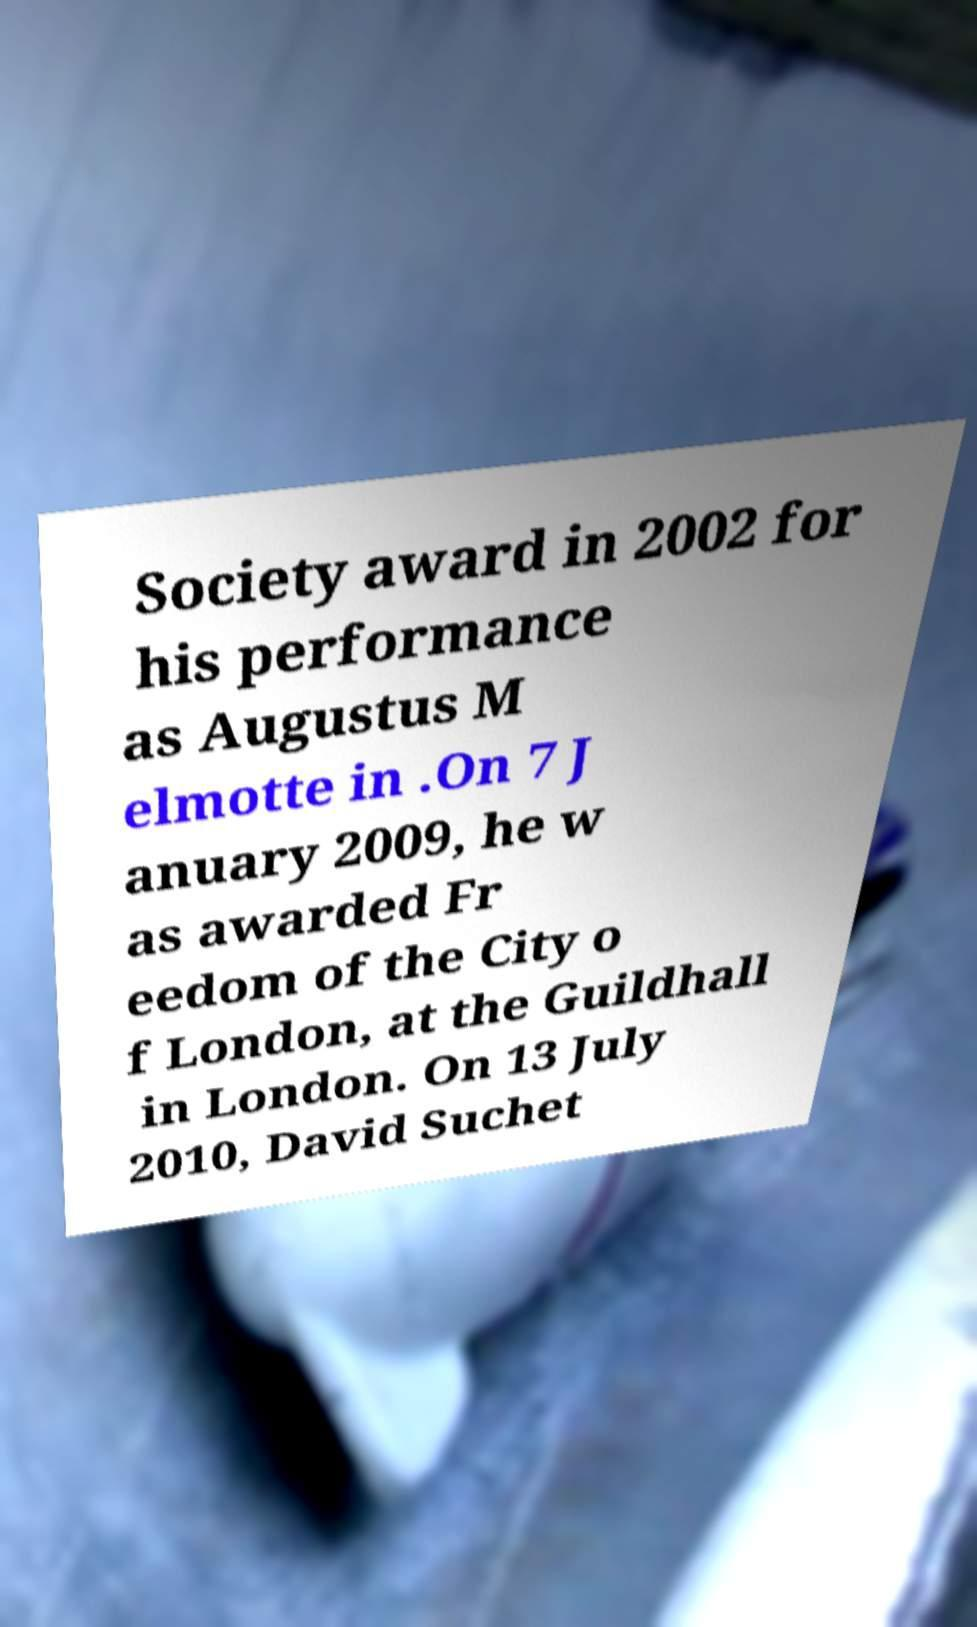For documentation purposes, I need the text within this image transcribed. Could you provide that? Society award in 2002 for his performance as Augustus M elmotte in .On 7 J anuary 2009, he w as awarded Fr eedom of the City o f London, at the Guildhall in London. On 13 July 2010, David Suchet 